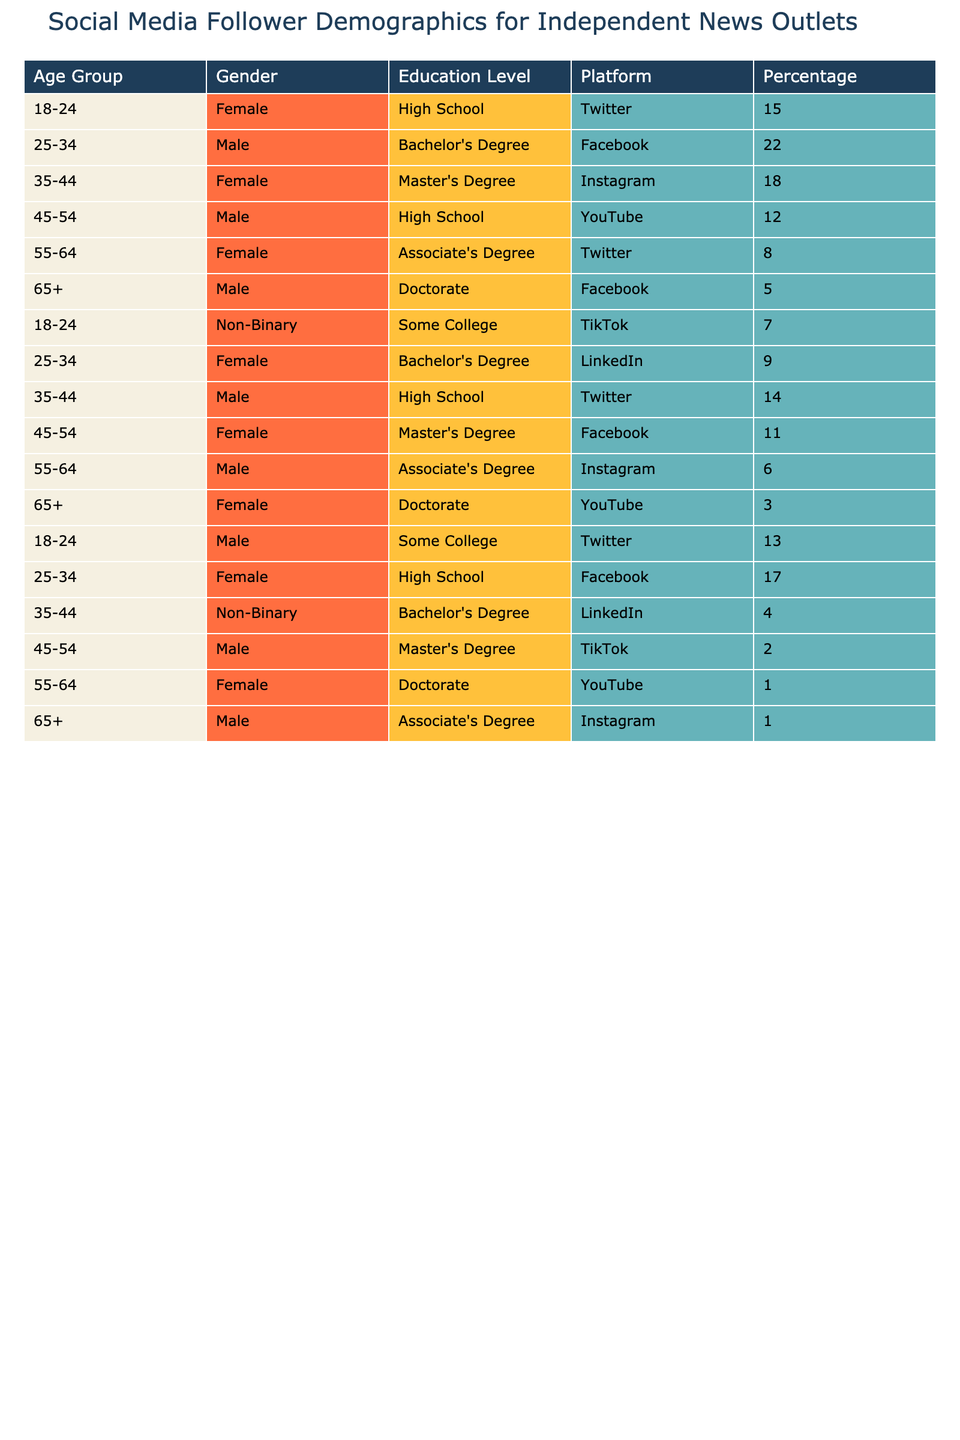What percentage of followers in the 18-24 age group are female? In the table, the only entry for the 18-24 age group that identifies a gender is the female category with a percentage of 15.
Answer: 15 Which platform has the highest percentage of followers in the 25-34 age group? The table shows that Facebook has the highest percentage for the 25-34 age group at 22%.
Answer: Facebook Is there a noticeable trend in female followers across the 35-44 age group on Instagram? The table indicates that the female percentage for the 35-44 age group on Instagram is 18%, which is consistent but lacks comparative data for other platforms in this group.
Answer: Yes, consistent What is the combined percentage of followers aged 45-54 who have a Master's Degree? The table shows 11% for female and 2% for male followers with a Master's Degree, summing these gives 13%.
Answer: 13 Which gender has a higher percentage of followers in the 55-64 age group across all education levels? For the 55-64 age group, the table lists 8% (female) and 6% (male) across different platforms, showing that female followers have a higher percentage.
Answer: Female What is the total percentage of young followers (ages 18-24) across all platforms? Summing the percentages for the 18-24 age group reveals: 15% (female, Twitter), 7% (non-binary, TikTok), and 13% (male, Twitter) = 35%.
Answer: 35 Is the representation of non-binary followers significant in the 25-34 age group compared to their male counterparts? The table shows 4% for non-binary followers (35-44, LinkedIn) compared to 22% for males (25-34, Facebook), indicating a smaller representation for non-binary individuals.
Answer: No, it's lower What percentage of followers aged 65+ have achieved a Doctorate? The table lists 5% for male and 3% for female followers in the 65+ age group with a Doctorate, adding these gives a total of 8%.
Answer: 8 Which education level has the highest overall representation among female followers aged 45-54? The table lists 11% for females with a Master's Degree and 12% with a high school level, indicating High School has the highest overall representation.
Answer: High School In the overall data, which platform predominantly attracts followers aged 55-64? Analyzing the data, Twitter has 8%, Instagram has 6%, and YouTube has 1%, making Twitter the dominant platform for 55-64 age group followers.
Answer: Twitter 